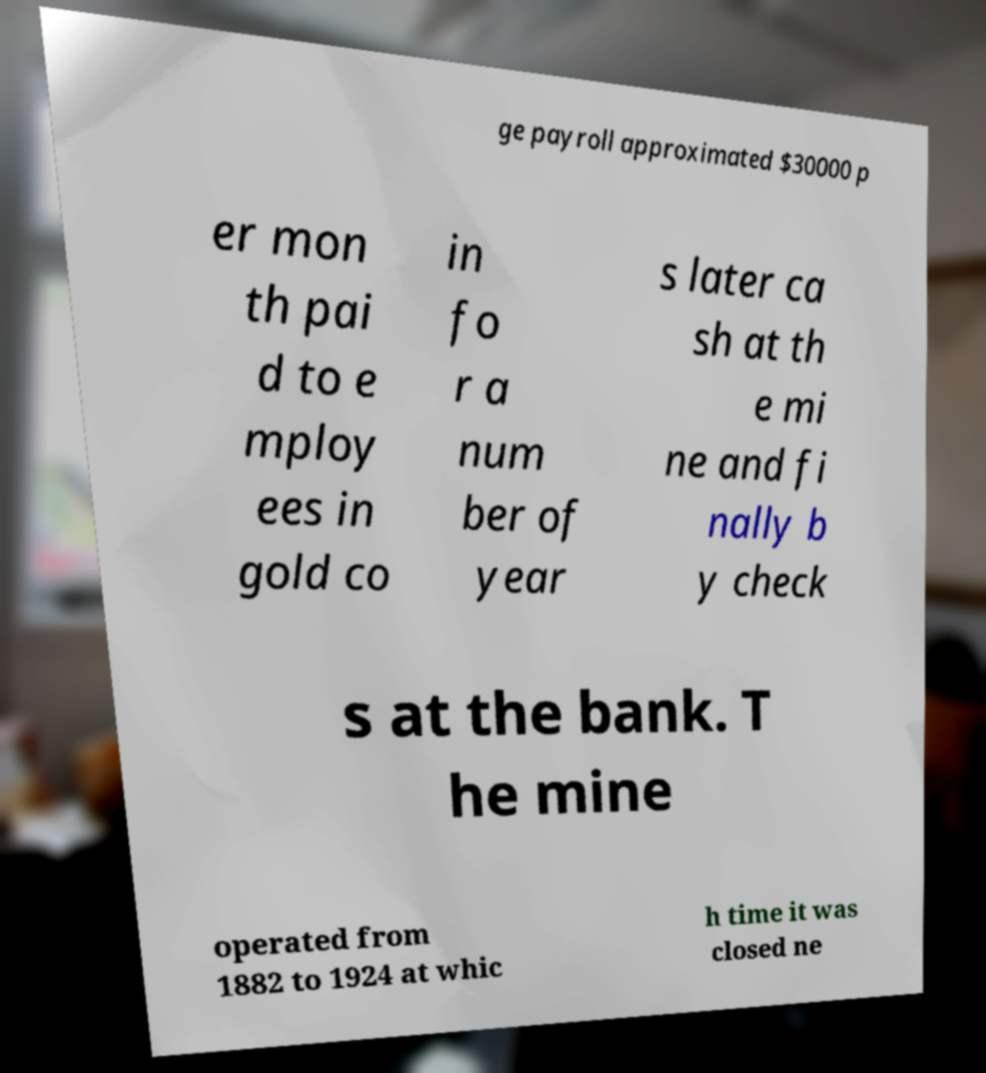Can you accurately transcribe the text from the provided image for me? ge payroll approximated $30000 p er mon th pai d to e mploy ees in gold co in fo r a num ber of year s later ca sh at th e mi ne and fi nally b y check s at the bank. T he mine operated from 1882 to 1924 at whic h time it was closed ne 